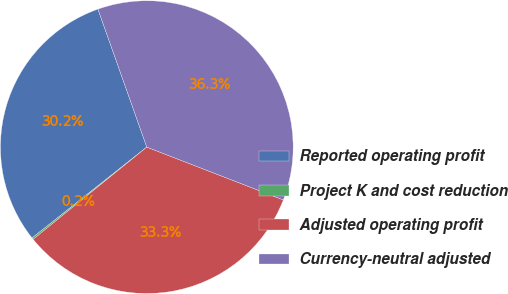Convert chart to OTSL. <chart><loc_0><loc_0><loc_500><loc_500><pie_chart><fcel>Reported operating profit<fcel>Project K and cost reduction<fcel>Adjusted operating profit<fcel>Currency-neutral adjusted<nl><fcel>30.24%<fcel>0.19%<fcel>33.27%<fcel>36.29%<nl></chart> 